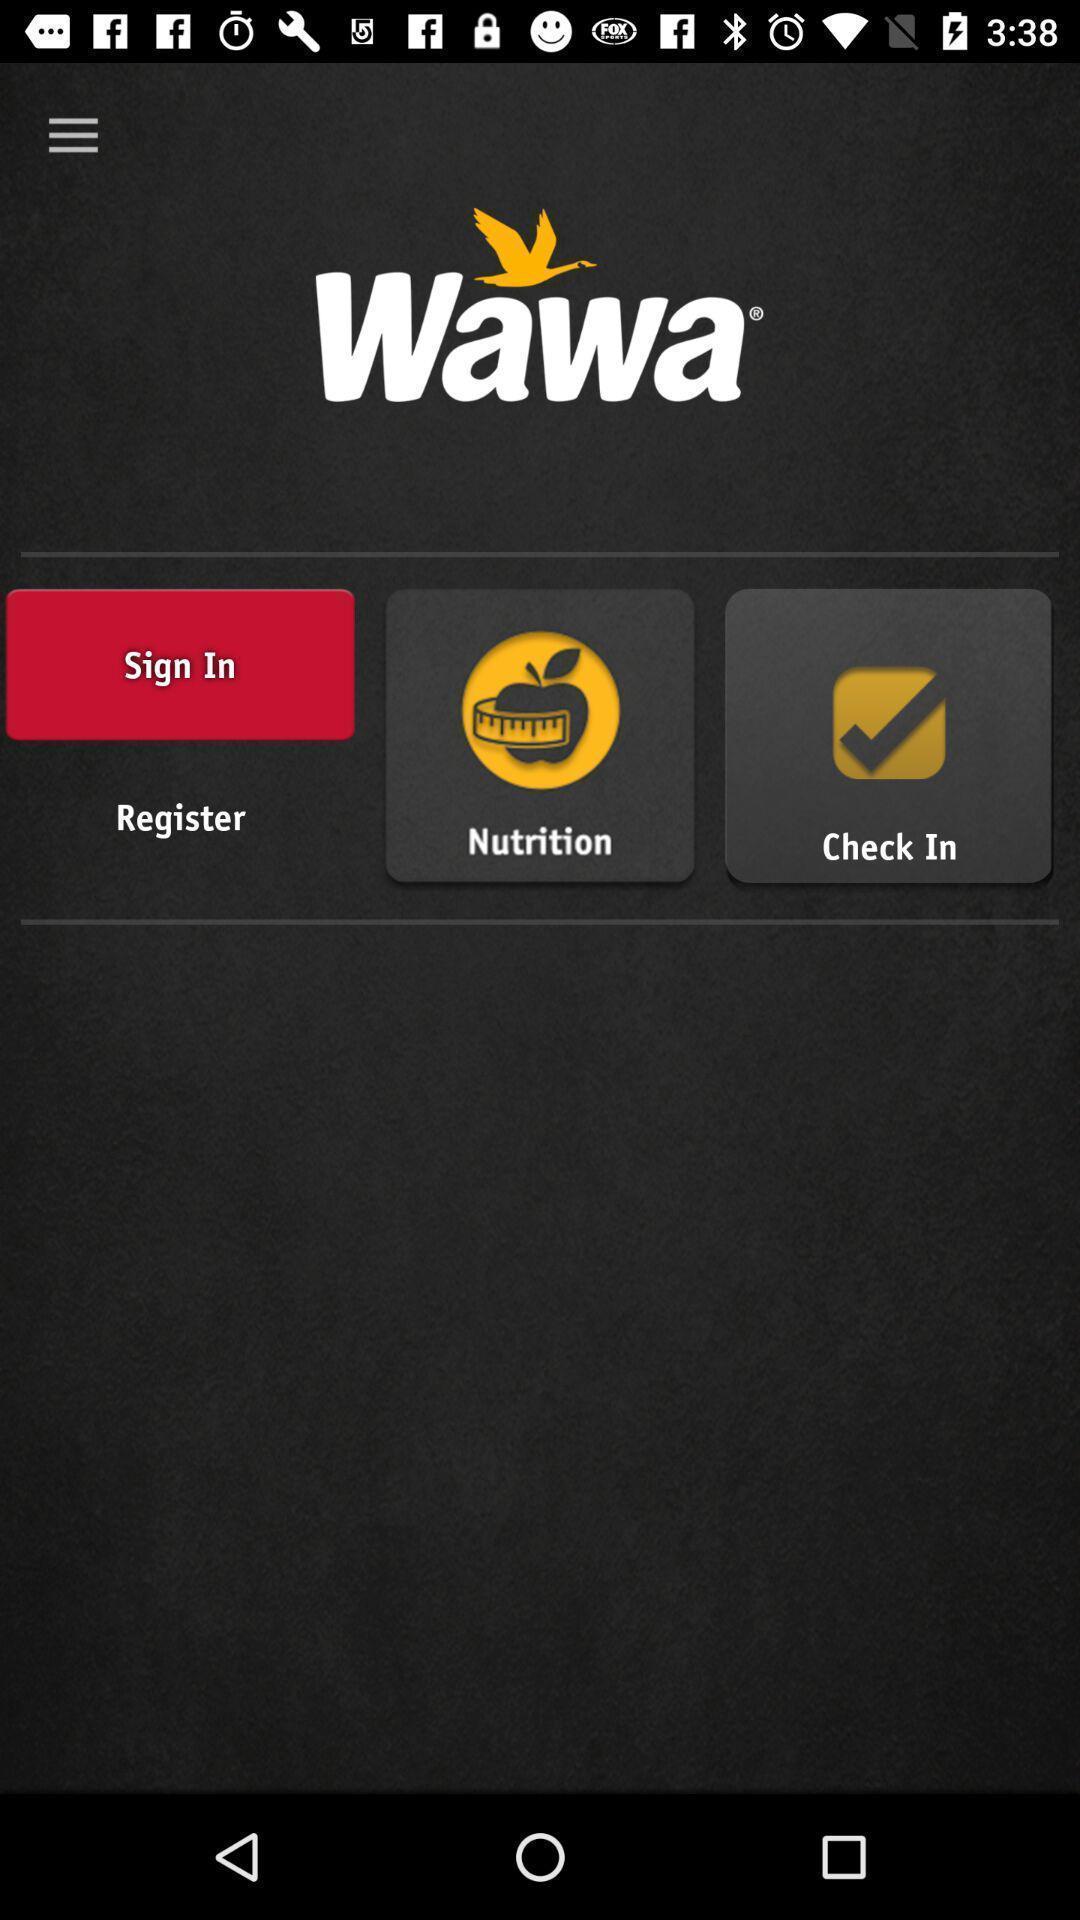Summarize the information in this screenshot. Sign up page. 